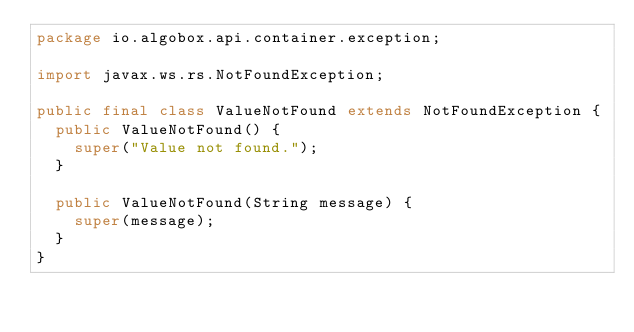Convert code to text. <code><loc_0><loc_0><loc_500><loc_500><_Java_>package io.algobox.api.container.exception;

import javax.ws.rs.NotFoundException;

public final class ValueNotFound extends NotFoundException {
  public ValueNotFound() {
    super("Value not found.");
  }

  public ValueNotFound(String message) {
    super(message);
  }
}
</code> 